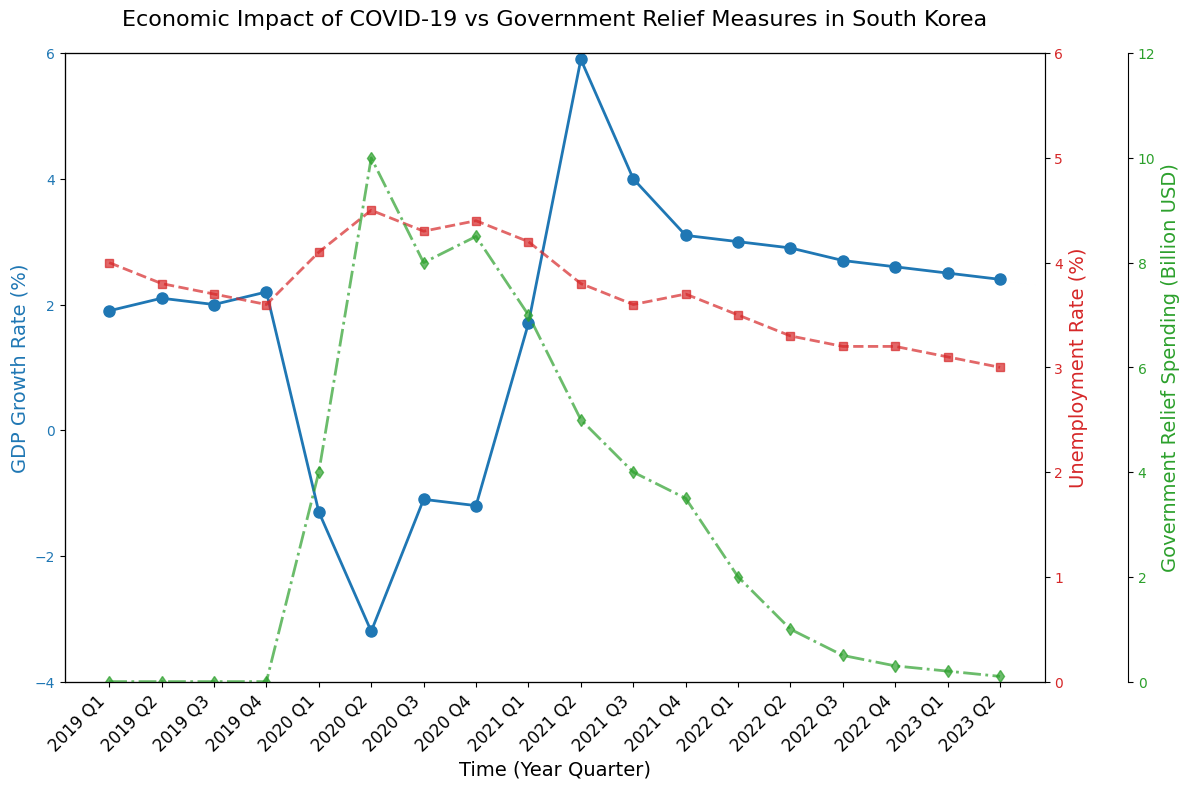What's the GDP growth rate in Q2 2020? Refer to the blue line representing GDP growth rate in Q2 2020 from the x-axis labels. The value is below 0, near -3.2%.
Answer: -3.2% How did the unemployment rate change from Q1 2020 to Q2 2020? Look at the red line with triangle markers for the unemployment rate at Q1 and Q2 2020. It increased from 4.1% to 4.5%.
Answer: Increased by 0.4% What is the difference in government relief spending between Q2 2020 and Q2 2021? Check the green line with diamond markers. Relief spending in Q2 2020 was 10 billion USD and in Q2 2021 was 5 billion USD. Difference is 5 billion USD.
Answer: 5 billion USD Which quarter in 2021 had the highest GDP growth rate? Identify the highest point on the blue line in 2021. The peak is in Q2 2021 with approximately 5.9%.
Answer: Q2 2021 How does the GDP growth rate in Q1 2023 compare to Q4 2019? Locate the blue line in Q1 2023 and Q4 2019. Q1 2023: approximately 2.5%. Q4 2019: approximately 2.2%. Compare the values; Q1 2023 is slightly higher.
Answer: Q1 2023 is higher by 0.3% In which quarter did the government relief spending start to decrease significantly? Follow the green line to observe where the steep decline starts. There is a noticeable drop between Q2 2020 (10 billion USD) and Q1 2021 (7 billion USD).
Answer: Q2 2020 to Q1 2021 What was the unemployment rate at the lowest point during the period shown? Review the red line for the lowest point, which occurs in Q2 2022 and Q2 2023. Both are at approximately 3.0%.
Answer: 3.0% Compare the unemployment rate and GDP growth rate in Q4 2021. Q4 2021: Unemployment rate (red line) approximate 3.7%, GDP growth rate (blue line) approximate 3.1%.
Answer: Unemployment rate: 3.7%, GDP growth rate: 3.1% During which quarter did both the GDP growth rate and government relief spending decrease simultaneously from the previous quarter? Check for synchronous declines on blue and green lines. Both values decrease from Q4 2020 to Q1 2021.
Answer: Q4 2020 to Q1 2021 